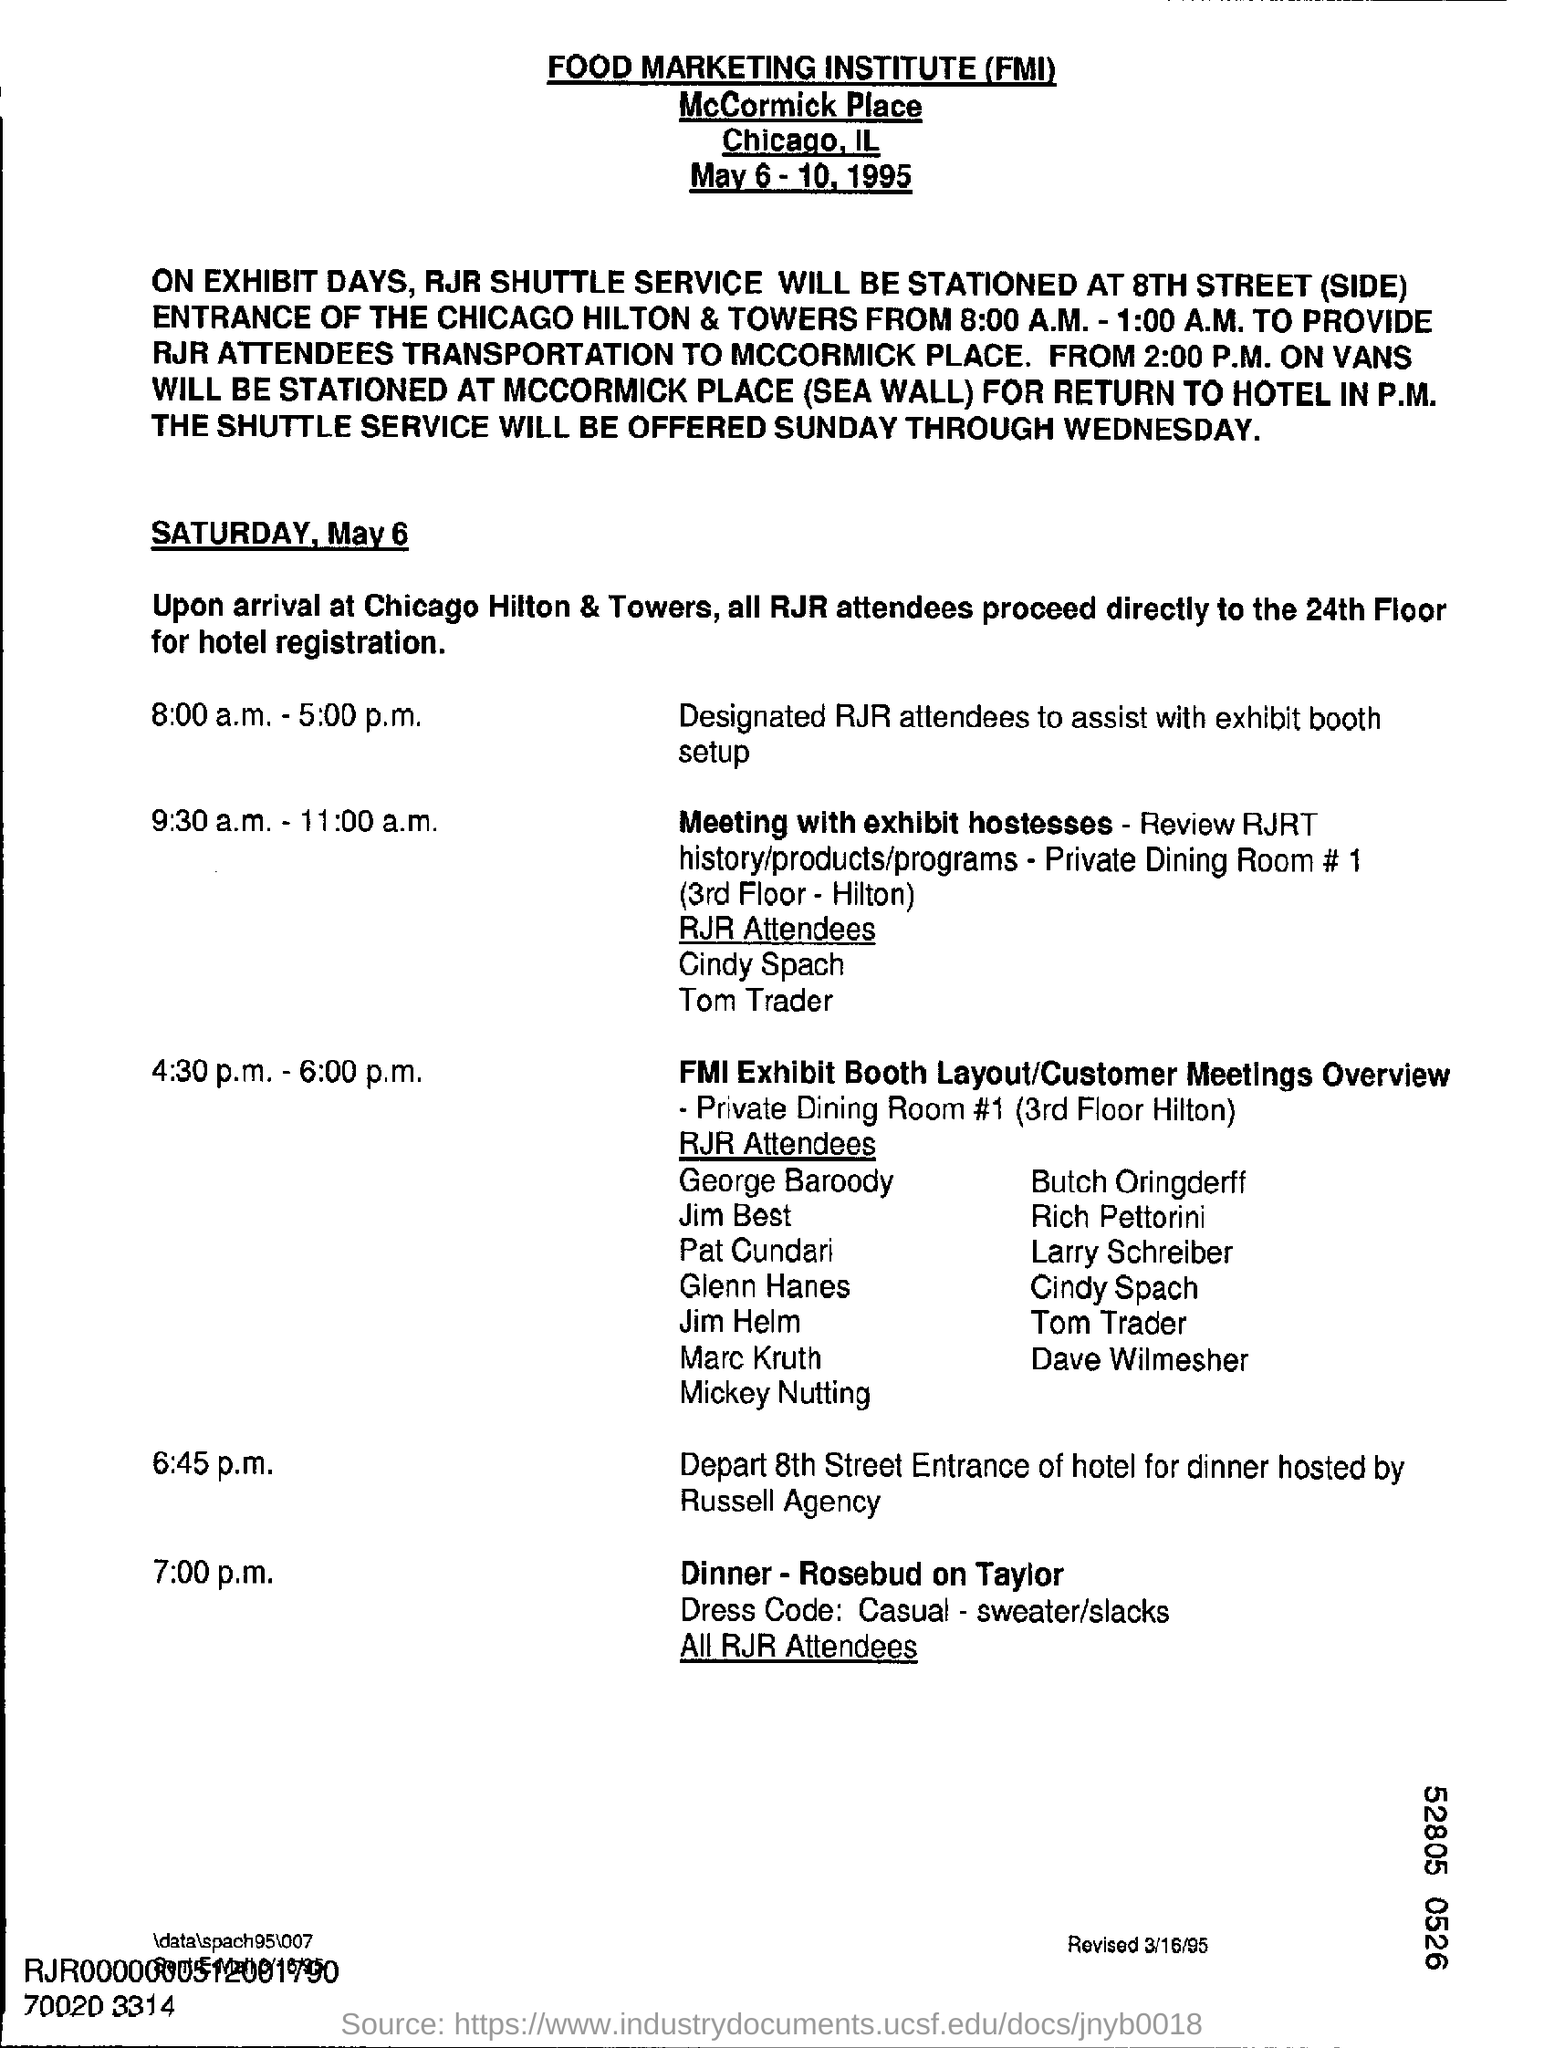Give some essential details in this illustration. The dress code for dinner at 7:00 p.m. is casual, which includes wearing a sweater and slacks. The document was revised on March 16, 1995. The full form of FMI is Food Marketing Institute. All attendees of the RJR event are to proceed directly to the 24th floor of the hotel for hotel registration. On Saturday, May 6, from 4:30 p.m. to 6:00 p.m., a program is scheduled. This program is related to FMI EXHIBIT BOOTH LAYOUT/CUSTOMER MEETINGS OVERVIEW. 